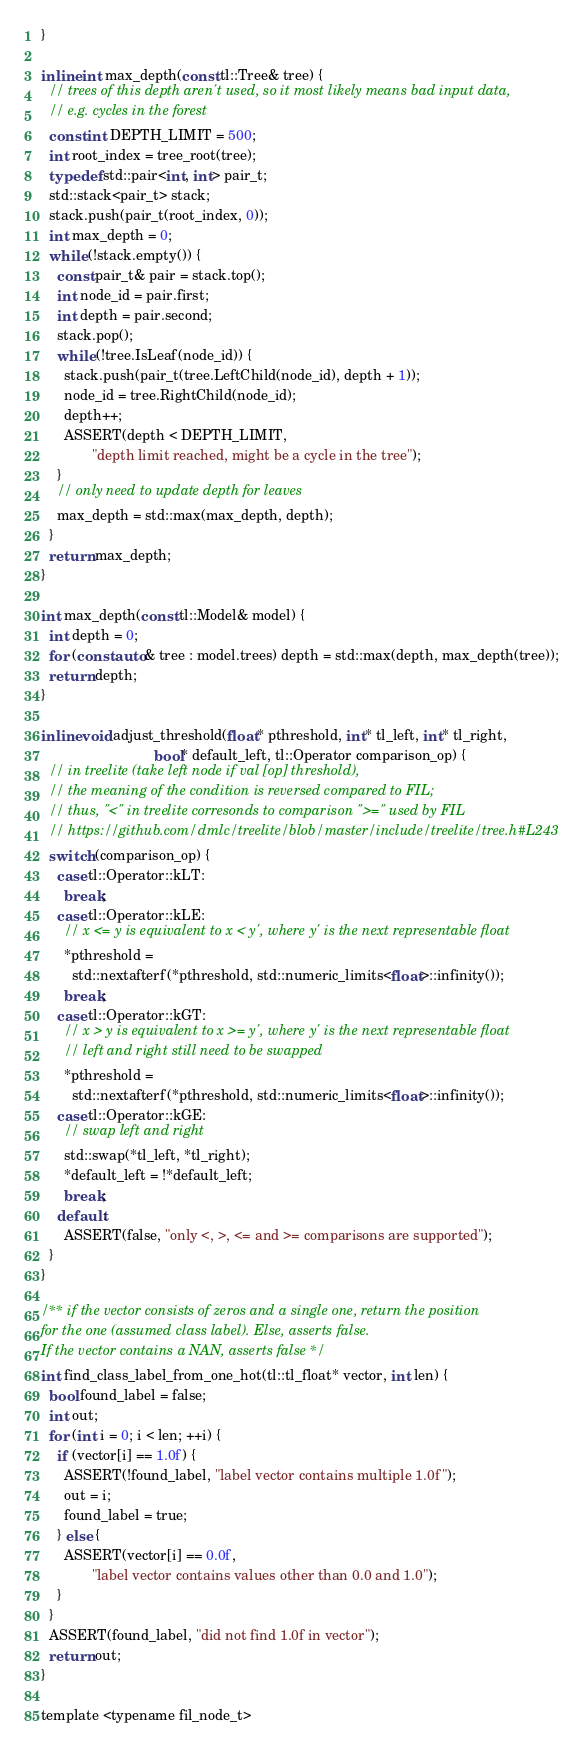<code> <loc_0><loc_0><loc_500><loc_500><_Cuda_>}

inline int max_depth(const tl::Tree& tree) {
  // trees of this depth aren't used, so it most likely means bad input data,
  // e.g. cycles in the forest
  const int DEPTH_LIMIT = 500;
  int root_index = tree_root(tree);
  typedef std::pair<int, int> pair_t;
  std::stack<pair_t> stack;
  stack.push(pair_t(root_index, 0));
  int max_depth = 0;
  while (!stack.empty()) {
    const pair_t& pair = stack.top();
    int node_id = pair.first;
    int depth = pair.second;
    stack.pop();
    while (!tree.IsLeaf(node_id)) {
      stack.push(pair_t(tree.LeftChild(node_id), depth + 1));
      node_id = tree.RightChild(node_id);
      depth++;
      ASSERT(depth < DEPTH_LIMIT,
             "depth limit reached, might be a cycle in the tree");
    }
    // only need to update depth for leaves
    max_depth = std::max(max_depth, depth);
  }
  return max_depth;
}

int max_depth(const tl::Model& model) {
  int depth = 0;
  for (const auto& tree : model.trees) depth = std::max(depth, max_depth(tree));
  return depth;
}

inline void adjust_threshold(float* pthreshold, int* tl_left, int* tl_right,
                             bool* default_left, tl::Operator comparison_op) {
  // in treelite (take left node if val [op] threshold),
  // the meaning of the condition is reversed compared to FIL;
  // thus, "<" in treelite corresonds to comparison ">=" used by FIL
  // https://github.com/dmlc/treelite/blob/master/include/treelite/tree.h#L243
  switch (comparison_op) {
    case tl::Operator::kLT:
      break;
    case tl::Operator::kLE:
      // x <= y is equivalent to x < y', where y' is the next representable float
      *pthreshold =
        std::nextafterf(*pthreshold, std::numeric_limits<float>::infinity());
      break;
    case tl::Operator::kGT:
      // x > y is equivalent to x >= y', where y' is the next representable float
      // left and right still need to be swapped
      *pthreshold =
        std::nextafterf(*pthreshold, std::numeric_limits<float>::infinity());
    case tl::Operator::kGE:
      // swap left and right
      std::swap(*tl_left, *tl_right);
      *default_left = !*default_left;
      break;
    default:
      ASSERT(false, "only <, >, <= and >= comparisons are supported");
  }
}

/** if the vector consists of zeros and a single one, return the position
for the one (assumed class label). Else, asserts false.
If the vector contains a NAN, asserts false */
int find_class_label_from_one_hot(tl::tl_float* vector, int len) {
  bool found_label = false;
  int out;
  for (int i = 0; i < len; ++i) {
    if (vector[i] == 1.0f) {
      ASSERT(!found_label, "label vector contains multiple 1.0f");
      out = i;
      found_label = true;
    } else {
      ASSERT(vector[i] == 0.0f,
             "label vector contains values other than 0.0 and 1.0");
    }
  }
  ASSERT(found_label, "did not find 1.0f in vector");
  return out;
}

template <typename fil_node_t></code> 